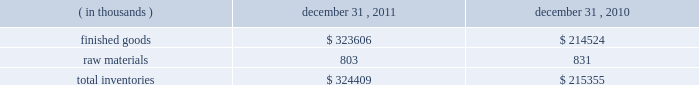Fair value of financial instruments the carrying amounts shown for the company 2019s cash and cash equivalents , accounts receivable and accounts payable approximate fair value because of the short term maturity of those instruments .
The fair value of the long term debt approximates its carrying value based on the variable nature of interest rates and current market rates available to the company .
The fair value of foreign currency forward contracts is based on the net difference between the u.s .
Dollars to be received or paid at the contracts 2019 settlement date and the u.s .
Dollar value of the foreign currency to be sold or purchased at the current forward exchange rate .
Recently issued accounting standards in june 2011 , the financial accounting standards board ( 201cfasb 201d ) issued an accounting standards update which eliminates the option to report other comprehensive income and its components in the statement of changes in stockholders 2019 equity .
It requires an entity to present total comprehensive income , which includes the components of net income and the components of other comprehensive income , either in a single continuous statement or in two separate but consecutive statements .
In december 2011 , the fasb issued an amendment to this pronouncement which defers the specific requirement to present components of reclassifications of other comprehensive income on the face of the income statement .
These pronouncements are effective for financial statements issued for fiscal years , and interim periods within those years , beginning after december 15 , 2011 .
The company believes the adoption of these pronouncements will not have a material impact on its consolidated financial statements .
In may 2011 , the fasb issued an accounting standards update which clarifies requirements for how to measure fair value and for disclosing information about fair value measurements common to accounting principles generally accepted in the united states of america and international financial reporting standards .
This guidance is effective for interim and annual periods beginning on or after december 15 , 2011 .
The company believes the adoption of this guidance will not have a material impact on its consolidated financial statements .
Inventories inventories consisted of the following: .
Acquisitions in july 2011 , the company acquired approximately 400.0 thousand square feet of office space comprising its corporate headquarters for $ 60.5 million .
The acquisition included land , buildings , tenant improvements and third party lease-related intangible assets .
As of the purchase date , 163.6 thousand square feet of the 400.0 thousand square feet acquired was leased to third party tenants .
These leases had remaining lease terms ranging from 9 months to 15 years on the purchase date .
The company intends to occupy additional space as it becomes available .
Since the acquisition , the company has invested $ 2.2 million in additional improvements .
The acquisition included the assumption of a $ 38.6 million loan secured by the property and the remaining purchase price was paid in cash funded primarily by a $ 25.0 million term loan borrowed in may 2011 .
The carrying value of the assumed loan approximated its fair value on the date of the acquisition .
Refer to note 7 for .
What was the percentage change in the inventory of finished goods from 2010 to 2011? 
Rationale: the inventory of finished goods increased by 50.8% from 2010 to 2011
Computations: ((323606 - 214524) / 214524)
Answer: 0.50848. 